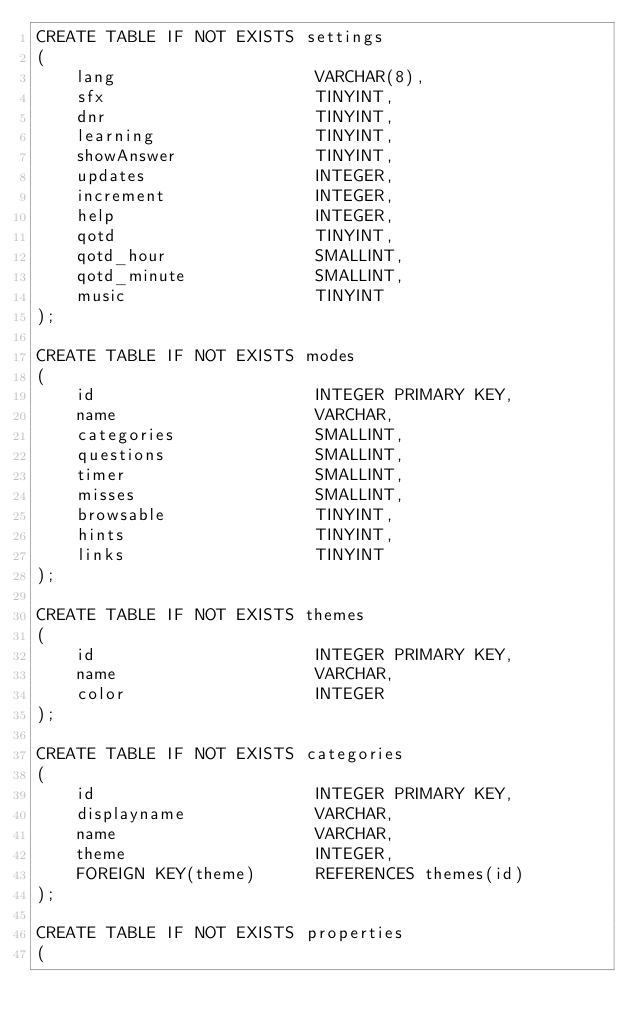<code> <loc_0><loc_0><loc_500><loc_500><_SQL_>CREATE TABLE IF NOT EXISTS settings
(
    lang                    VARCHAR(8),
    sfx                     TINYINT,
    dnr                     TINYINT,
    learning                TINYINT,
    showAnswer              TINYINT,
    updates                 INTEGER,
    increment               INTEGER,
    help                    INTEGER,
    qotd                    TINYINT,
    qotd_hour               SMALLINT,
    qotd_minute             SMALLINT,
    music                   TINYINT
);

CREATE TABLE IF NOT EXISTS modes
(
    id                      INTEGER PRIMARY KEY,
    name                    VARCHAR,
    categories              SMALLINT,
    questions               SMALLINT,
    timer                   SMALLINT,
    misses                  SMALLINT,
    browsable               TINYINT,
    hints                   TINYINT,
    links                   TINYINT
);

CREATE TABLE IF NOT EXISTS themes
(
    id                      INTEGER PRIMARY KEY,
    name                    VARCHAR,
    color                   INTEGER
);

CREATE TABLE IF NOT EXISTS categories
(
    id                      INTEGER PRIMARY KEY,
    displayname             VARCHAR,
    name                    VARCHAR,
    theme                   INTEGER,
    FOREIGN KEY(theme)      REFERENCES themes(id)
);

CREATE TABLE IF NOT EXISTS properties
(</code> 